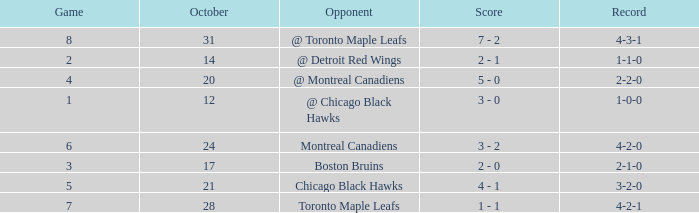What was the score of the game after game 6 on October 28? 1 - 1. Could you parse the entire table? {'header': ['Game', 'October', 'Opponent', 'Score', 'Record'], 'rows': [['8', '31', '@ Toronto Maple Leafs', '7 - 2', '4-3-1'], ['2', '14', '@ Detroit Red Wings', '2 - 1', '1-1-0'], ['4', '20', '@ Montreal Canadiens', '5 - 0', '2-2-0'], ['1', '12', '@ Chicago Black Hawks', '3 - 0', '1-0-0'], ['6', '24', 'Montreal Canadiens', '3 - 2', '4-2-0'], ['3', '17', 'Boston Bruins', '2 - 0', '2-1-0'], ['5', '21', 'Chicago Black Hawks', '4 - 1', '3-2-0'], ['7', '28', 'Toronto Maple Leafs', '1 - 1', '4-2-1']]} 